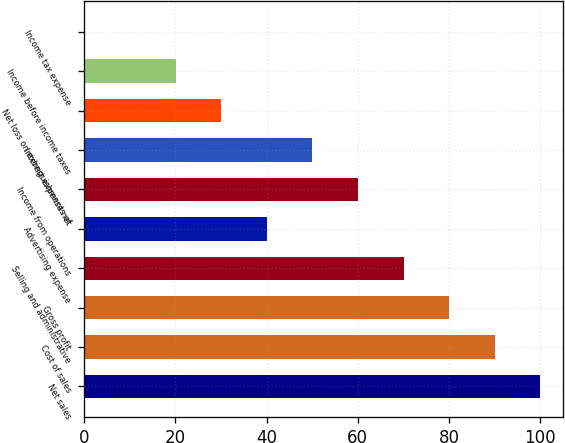Convert chart to OTSL. <chart><loc_0><loc_0><loc_500><loc_500><bar_chart><fcel>Net sales<fcel>Cost of sales<fcel>Gross profit<fcel>Selling and administrative<fcel>Advertising expense<fcel>Income from operations<fcel>Interest expense net<fcel>Net loss on extinguishments of<fcel>Income before income taxes<fcel>Income tax expense<nl><fcel>100<fcel>90.01<fcel>80.02<fcel>70.03<fcel>40.06<fcel>60.04<fcel>50.05<fcel>30.07<fcel>20.08<fcel>0.1<nl></chart> 